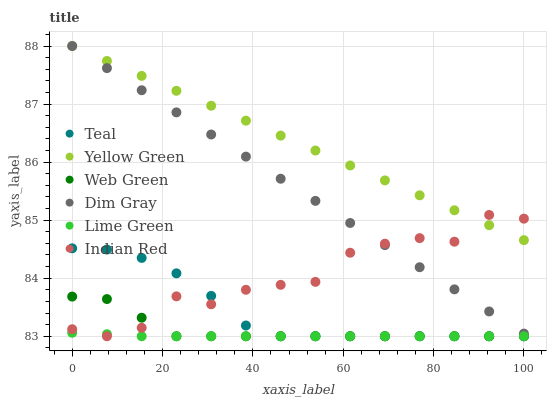Does Lime Green have the minimum area under the curve?
Answer yes or no. Yes. Does Yellow Green have the maximum area under the curve?
Answer yes or no. Yes. Does Dim Gray have the minimum area under the curve?
Answer yes or no. No. Does Dim Gray have the maximum area under the curve?
Answer yes or no. No. Is Yellow Green the smoothest?
Answer yes or no. Yes. Is Indian Red the roughest?
Answer yes or no. Yes. Is Dim Gray the smoothest?
Answer yes or no. No. Is Dim Gray the roughest?
Answer yes or no. No. Does Teal have the lowest value?
Answer yes or no. Yes. Does Dim Gray have the lowest value?
Answer yes or no. No. Does Yellow Green have the highest value?
Answer yes or no. Yes. Does Web Green have the highest value?
Answer yes or no. No. Is Web Green less than Dim Gray?
Answer yes or no. Yes. Is Yellow Green greater than Teal?
Answer yes or no. Yes. Does Indian Red intersect Dim Gray?
Answer yes or no. Yes. Is Indian Red less than Dim Gray?
Answer yes or no. No. Is Indian Red greater than Dim Gray?
Answer yes or no. No. Does Web Green intersect Dim Gray?
Answer yes or no. No. 